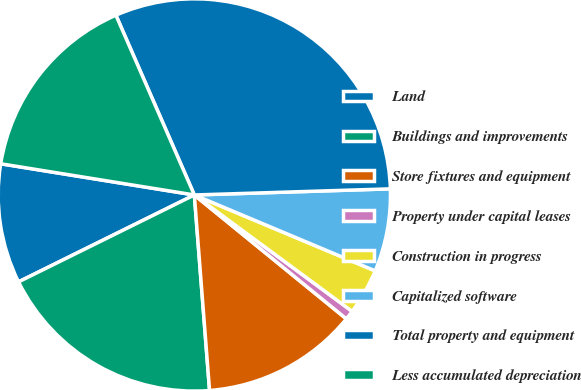<chart> <loc_0><loc_0><loc_500><loc_500><pie_chart><fcel>Land<fcel>Buildings and improvements<fcel>Store fixtures and equipment<fcel>Property under capital leases<fcel>Construction in progress<fcel>Capitalized software<fcel>Total property and equipment<fcel>Less accumulated depreciation<nl><fcel>9.85%<fcel>18.93%<fcel>12.88%<fcel>0.77%<fcel>3.79%<fcel>6.82%<fcel>31.05%<fcel>15.91%<nl></chart> 